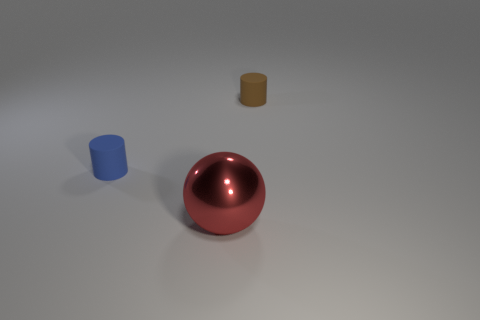Add 3 brown rubber cylinders. How many objects exist? 6 Subtract 1 spheres. How many spheres are left? 0 Subtract all blue cylinders. How many cylinders are left? 1 Subtract all spheres. How many objects are left? 2 Subtract all purple balls. Subtract all red blocks. How many balls are left? 1 Subtract all cyan blocks. How many green spheres are left? 0 Subtract all matte things. Subtract all small brown matte cylinders. How many objects are left? 0 Add 1 tiny brown matte cylinders. How many tiny brown matte cylinders are left? 2 Add 1 tiny matte objects. How many tiny matte objects exist? 3 Subtract 0 yellow blocks. How many objects are left? 3 